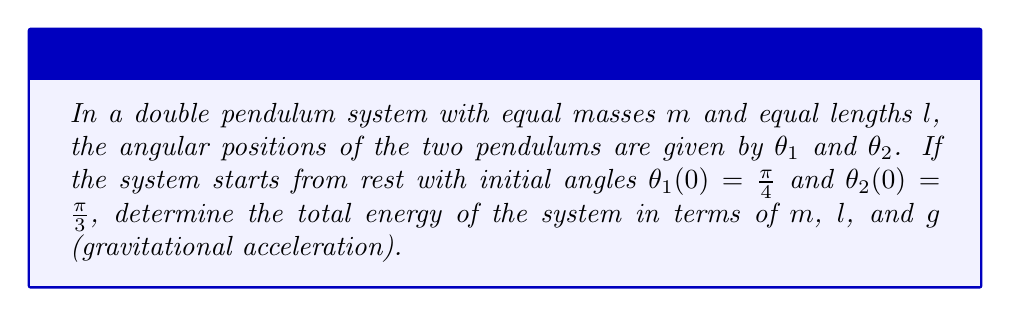Provide a solution to this math problem. To solve this problem, we'll follow these steps:

1) The total energy of a double pendulum system is the sum of kinetic and potential energies:
   $E_{total} = KE + PE$

2) Since the system starts from rest, the initial kinetic energy is zero:
   $KE_{initial} = 0$

3) The potential energy of a double pendulum is given by:
   $PE = -mgl(\cos\theta_1 + \cos\theta_2)$

4) Substitute the initial angles:
   $PE = -mgl(\cos(\frac{\pi}{4}) + \cos(\frac{\pi}{3}))$

5) Simplify using known trigonometric values:
   $\cos(\frac{\pi}{4}) = \frac{\sqrt{2}}{2}$
   $\cos(\frac{\pi}{3}) = \frac{1}{2}$

6) Substitute these values:
   $PE = -mgl(\frac{\sqrt{2}}{2} + \frac{1}{2})$

7) Factor out $mgl$:
   $PE = -mgl(\frac{\sqrt{2} + 1}{2})$

8) The total energy is equal to the initial potential energy:
   $E_{total} = PE = -mgl(\frac{\sqrt{2} + 1}{2})$
Answer: $-mgl(\frac{\sqrt{2} + 1}{2})$ 